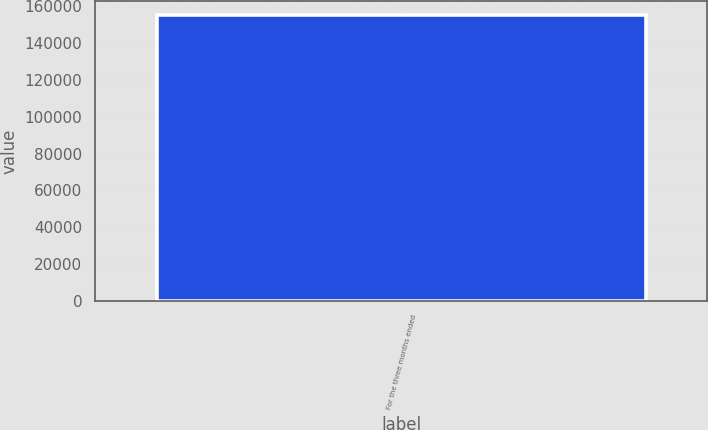Convert chart to OTSL. <chart><loc_0><loc_0><loc_500><loc_500><bar_chart><fcel>For the three months ended<nl><fcel>155198<nl></chart> 